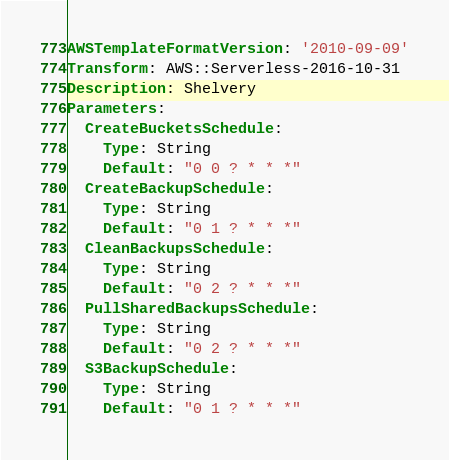<code> <loc_0><loc_0><loc_500><loc_500><_YAML_>AWSTemplateFormatVersion: '2010-09-09'
Transform: AWS::Serverless-2016-10-31
Description: Shelvery
Parameters:
  CreateBucketsSchedule:
    Type: String
    Default: "0 0 ? * * *"
  CreateBackupSchedule:
    Type: String
    Default: "0 1 ? * * *"
  CleanBackupsSchedule:
    Type: String
    Default: "0 2 ? * * *"
  PullSharedBackupsSchedule:
    Type: String
    Default: "0 2 ? * * *"
  S3BackupSchedule:
    Type: String
    Default: "0 1 ? * * *"</code> 